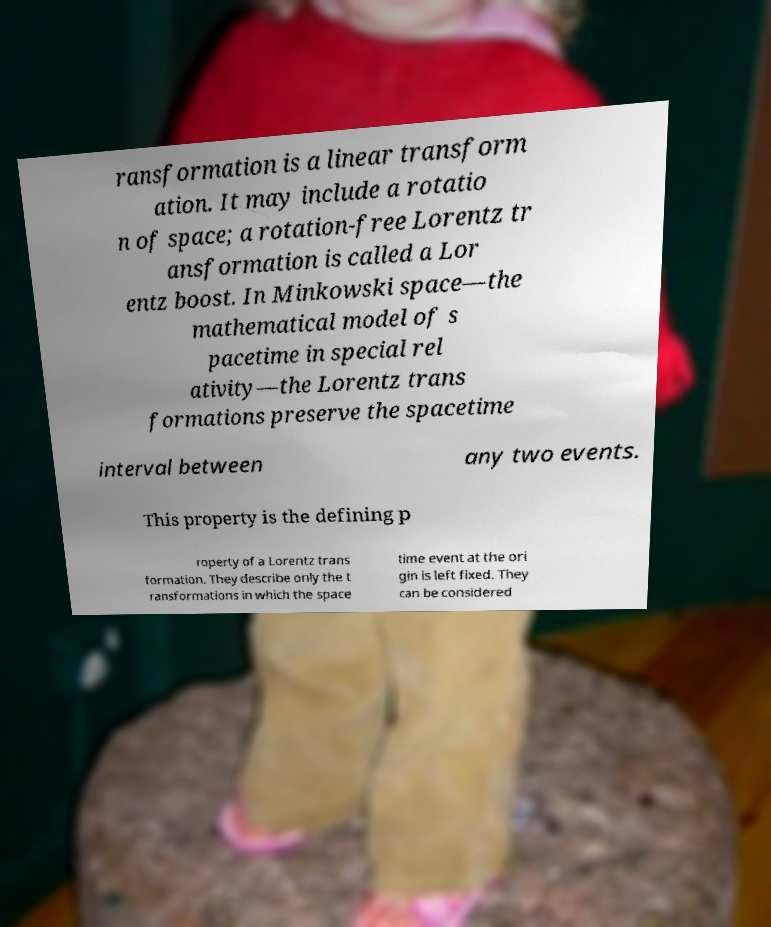For documentation purposes, I need the text within this image transcribed. Could you provide that? ransformation is a linear transform ation. It may include a rotatio n of space; a rotation-free Lorentz tr ansformation is called a Lor entz boost. In Minkowski space—the mathematical model of s pacetime in special rel ativity—the Lorentz trans formations preserve the spacetime interval between any two events. This property is the defining p roperty of a Lorentz trans formation. They describe only the t ransformations in which the space time event at the ori gin is left fixed. They can be considered 